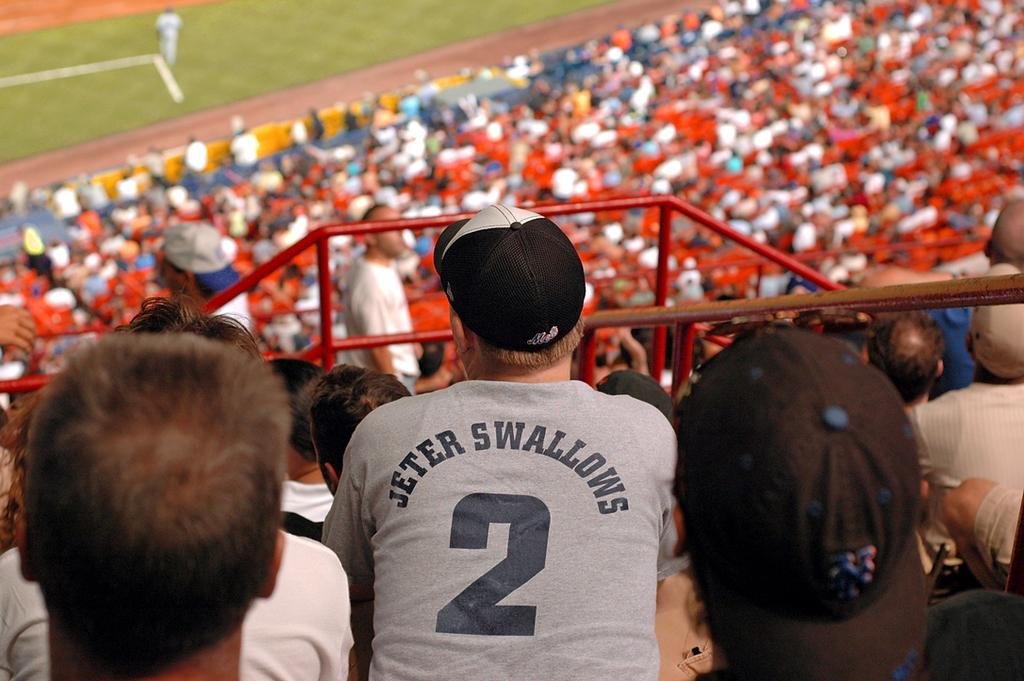Provide a one-sentence caption for the provided image. a man at a baseball game with Jeter Swallows 2 on the back of his shirt.. 